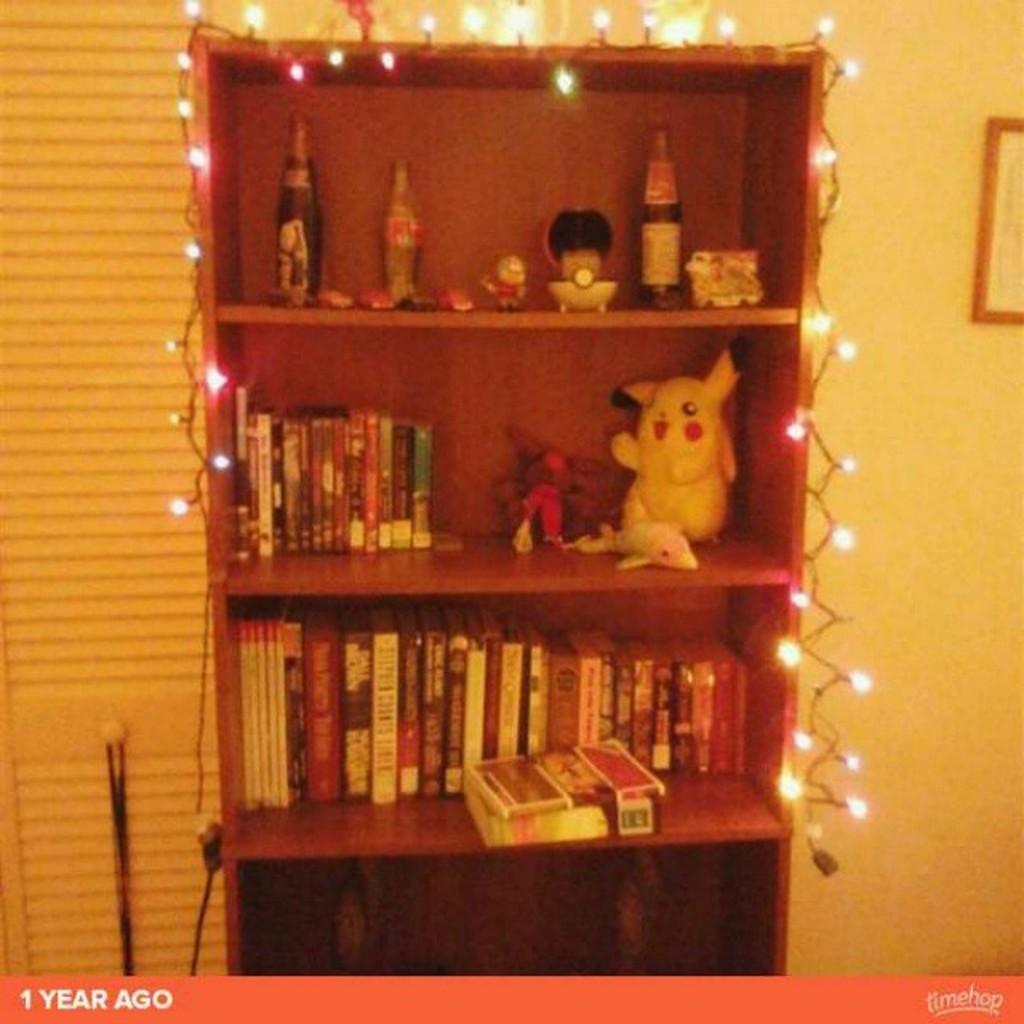Could you give a brief overview of what you see in this image? Here in this picture we can see a wooden shelf that is fully decorated with lights and in that we can see bottles present on the top and in the middle we can see some toys and DVDs present and below that we can see books present and on the right side we can see a portrait present on the wall. 